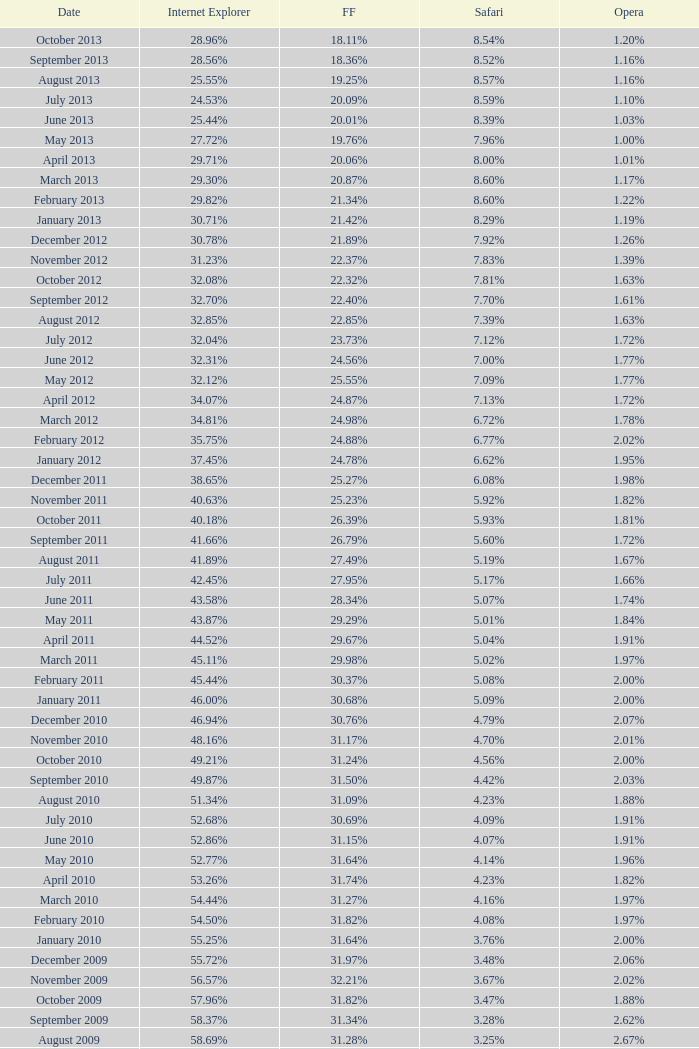What percentage of browsers were using Opera in October 2010? 2.00%. 